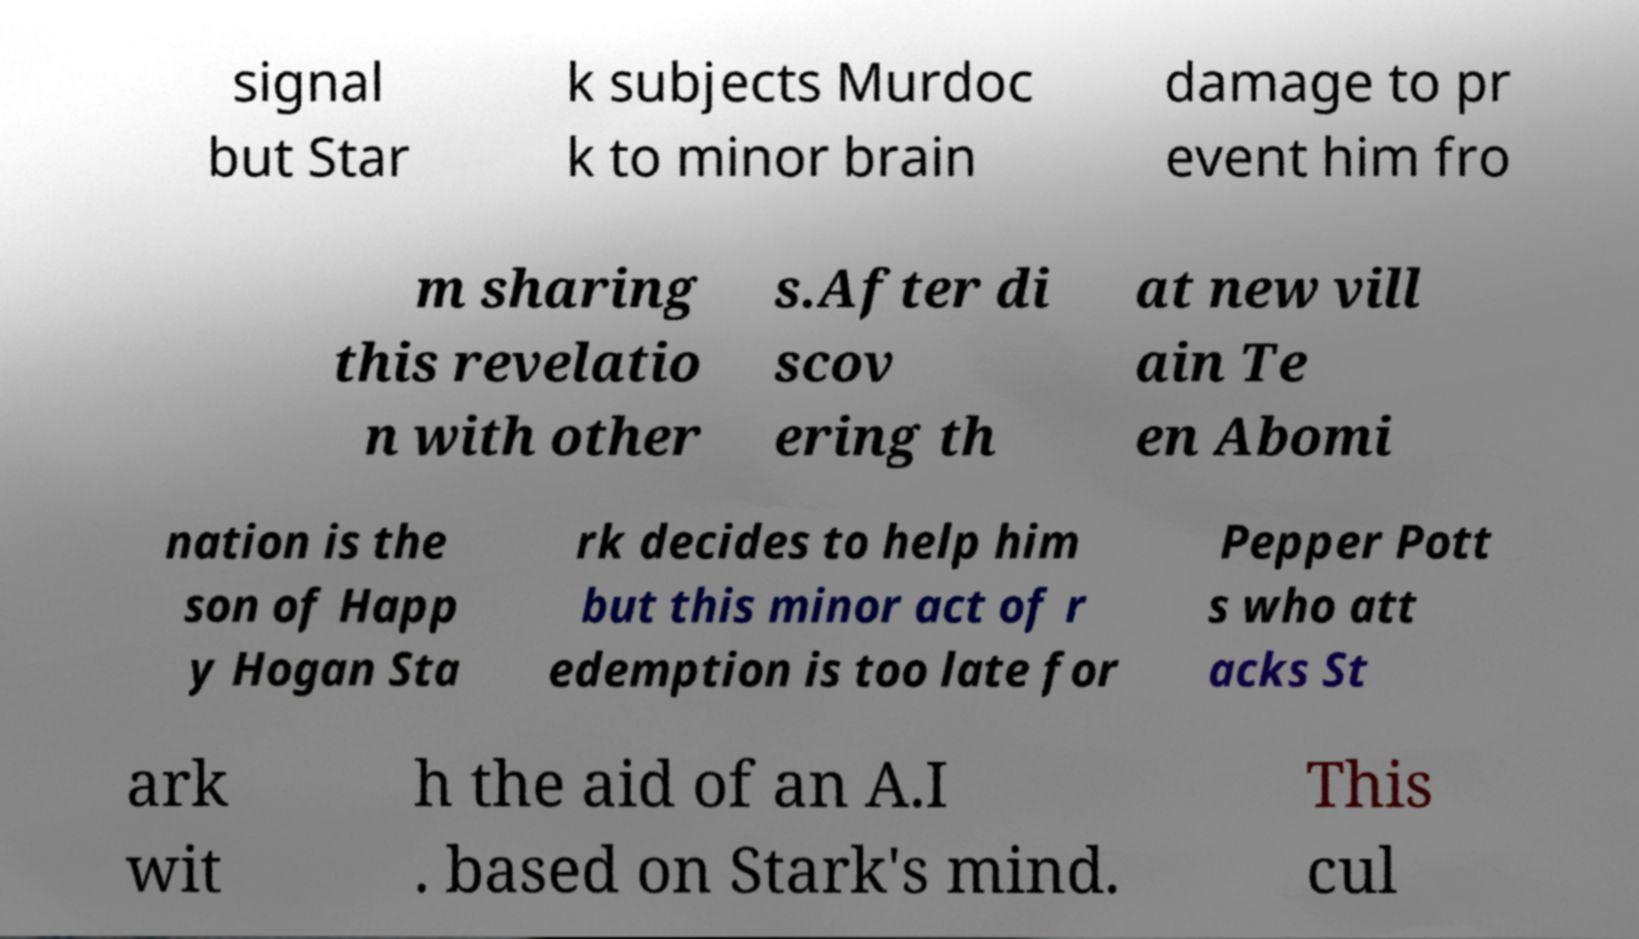What messages or text are displayed in this image? I need them in a readable, typed format. signal but Star k subjects Murdoc k to minor brain damage to pr event him fro m sharing this revelatio n with other s.After di scov ering th at new vill ain Te en Abomi nation is the son of Happ y Hogan Sta rk decides to help him but this minor act of r edemption is too late for Pepper Pott s who att acks St ark wit h the aid of an A.I . based on Stark's mind. This cul 